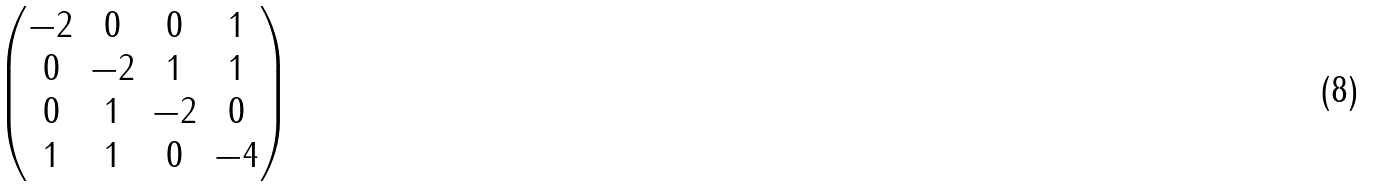Convert formula to latex. <formula><loc_0><loc_0><loc_500><loc_500>\begin{pmatrix} - 2 & 0 & 0 & 1 \\ 0 & - 2 & 1 & 1 \\ 0 & 1 & - 2 & 0 \\ 1 & 1 & 0 & - 4 \end{pmatrix}</formula> 